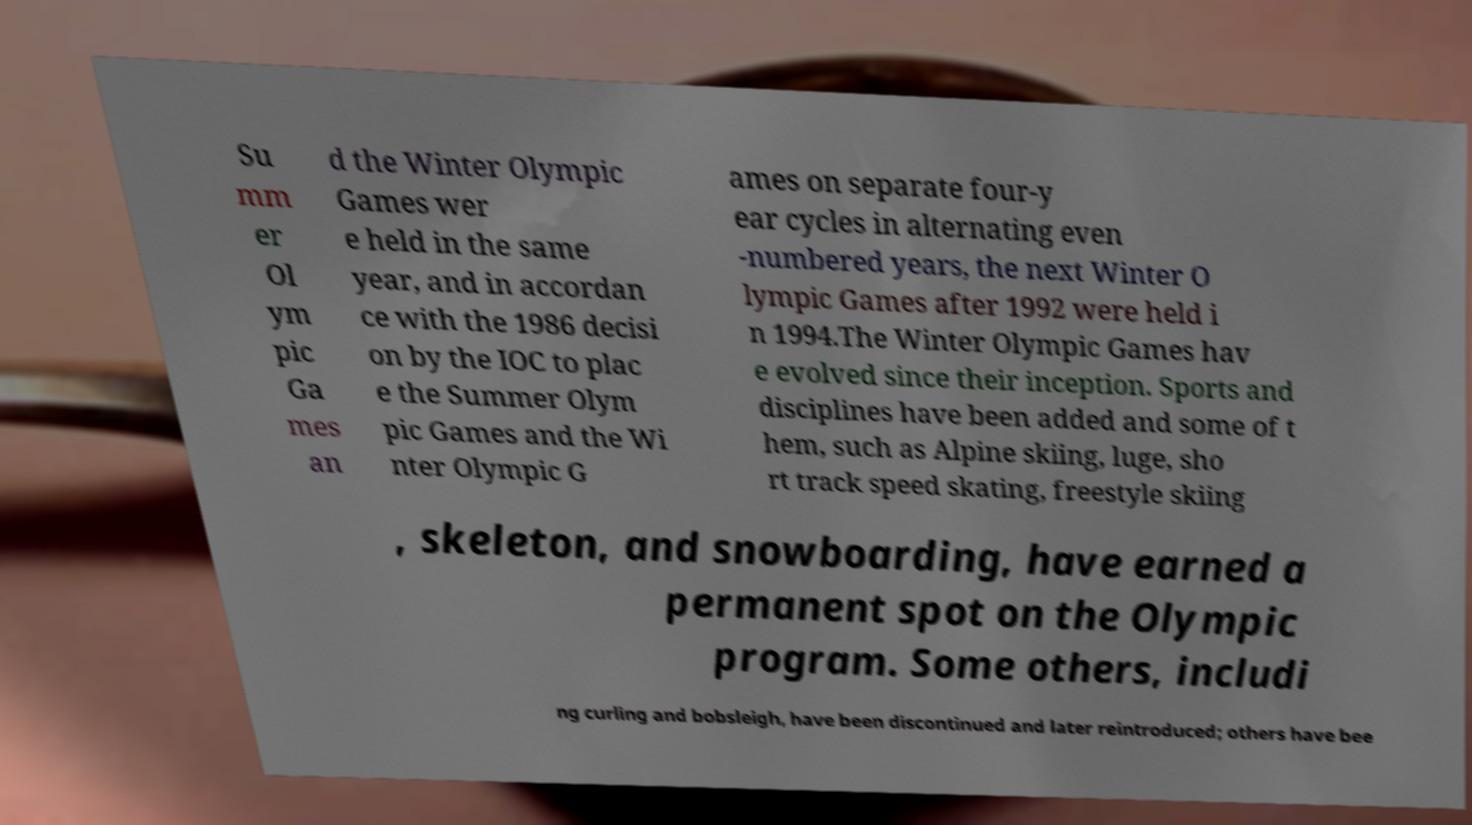There's text embedded in this image that I need extracted. Can you transcribe it verbatim? Su mm er Ol ym pic Ga mes an d the Winter Olympic Games wer e held in the same year, and in accordan ce with the 1986 decisi on by the IOC to plac e the Summer Olym pic Games and the Wi nter Olympic G ames on separate four-y ear cycles in alternating even -numbered years, the next Winter O lympic Games after 1992 were held i n 1994.The Winter Olympic Games hav e evolved since their inception. Sports and disciplines have been added and some of t hem, such as Alpine skiing, luge, sho rt track speed skating, freestyle skiing , skeleton, and snowboarding, have earned a permanent spot on the Olympic program. Some others, includi ng curling and bobsleigh, have been discontinued and later reintroduced; others have bee 